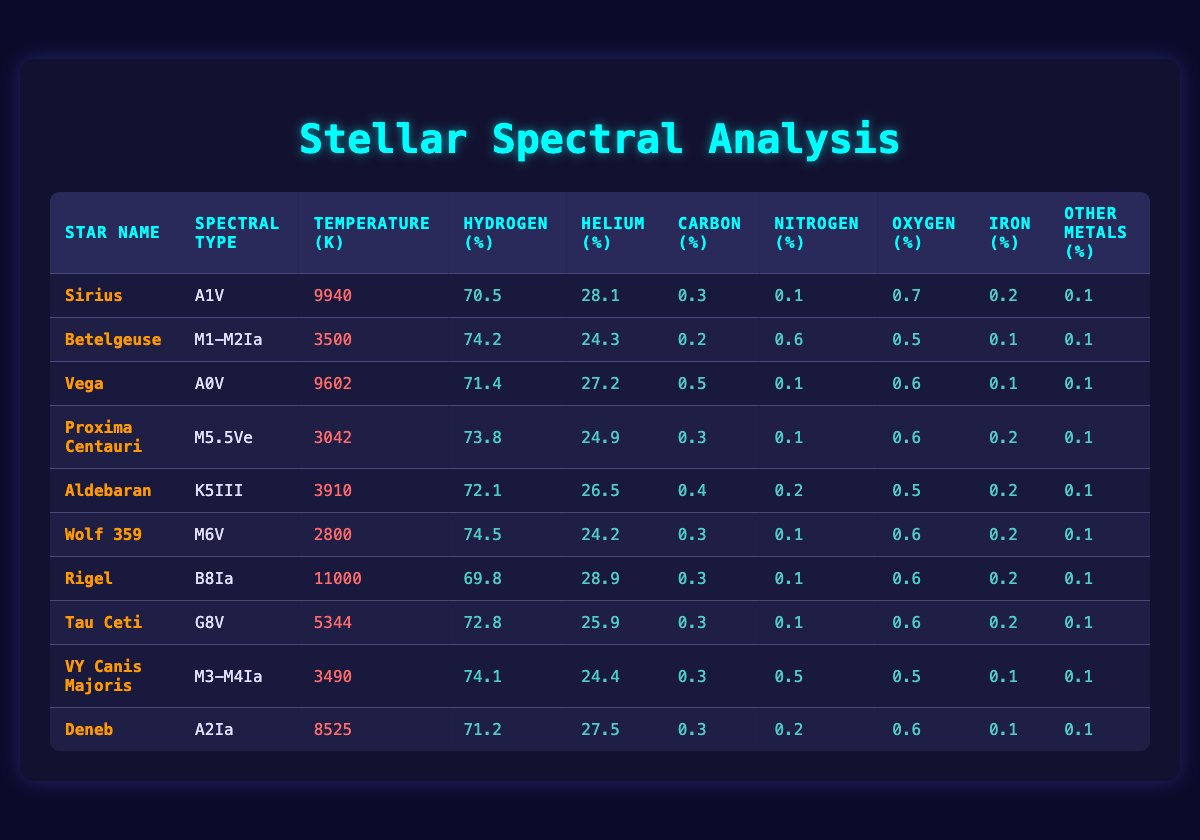What is the spectral type of Sirius? Referring to the table, I can find Sirius under the "Star Name" column and see that its spectral type is listed as A1V.
Answer: A1V Which star has the highest temperature? To determine the star with the highest temperature, I can look at the "Temperature (K)" column and find the maximum value, which is 11000, associated with the star Rigel.
Answer: Rigel How much carbon is present in Aldebaran? By looking at the row for Aldebaran, I can check the "Carbon (%)" column where it shows 0.4.
Answer: 0.4 What is the average temperature of all stars listed? First, I need to sum all the temperatures from the "Temperature (K)" column: 9940 + 3500 + 9602 + 3042 + 3910 + 2800 + 11000 + 5344 + 3490 + 8525 = 55453. There are 10 stars, so I divide this sum by 10, which yields an average of 5545.3.
Answer: 5545.3 Is the hydrogen percentage in Wolf 359 greater than 70%? I can find the row for Wolf 359 and check the "Hydrogen (%)" column where it shows 74.5, which is indeed greater than 70%.
Answer: Yes Which star has the least nitrogen percentage? Looking through the "Nitrogen (%)" column, I see both Proxima Centauri and Wolf 359 have 0.1, which is the lowest value present among the stars listed.
Answer: Proxima Centauri and Wolf 359 What is the total percentage of helium in all stars? I need to sum the "Helium (%)" values: 28.1 + 24.3 + 27.2 + 24.9 + 26.5 + 24.2 + 28.9 + 25.9 + 25.9 + 27.5 =  229.6. Since there are 10 stars, I calculate the average by dividing this total by 10: 229.6 / 10 = 22.96.
Answer: 22.96 Are there more than three stars with a temperature above 6000 K? I will check the "Temperature (K)" column and list the stars with temperatures above 6000 K. Only Sirius, Vega, Rigel, and Deneb meet this criterion, counting to four stars total. Thus, the answer is yes.
Answer: Yes What is the percentage of iron in Betelgeuse? Referring to the column for "Iron (%)" and the row for Betelgeuse, it shows a value of 0.1.
Answer: 0.1 